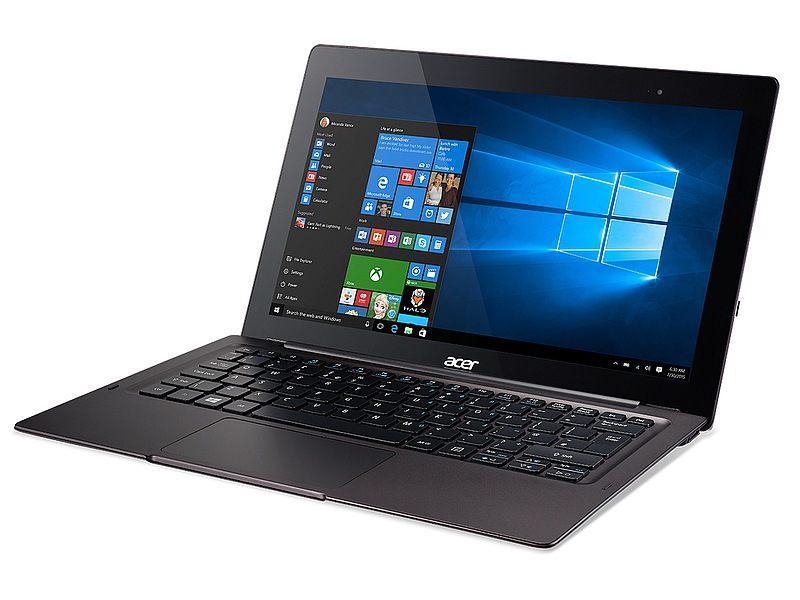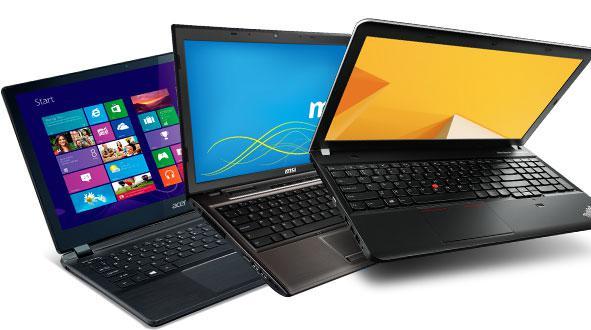The first image is the image on the left, the second image is the image on the right. Considering the images on both sides, is "The right image depicts three laptops." valid? Answer yes or no. Yes. The first image is the image on the left, the second image is the image on the right. Examine the images to the left and right. Is the description "The right image features three opened laptops." accurate? Answer yes or no. Yes. 